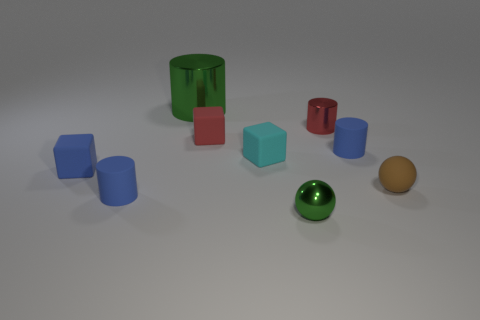Subtract all gray cylinders. Subtract all red blocks. How many cylinders are left? 4 Add 1 yellow shiny things. How many objects exist? 10 Subtract all balls. How many objects are left? 7 Subtract all small things. Subtract all small cyan blocks. How many objects are left? 0 Add 5 small shiny things. How many small shiny things are left? 7 Add 3 small balls. How many small balls exist? 5 Subtract 1 green cylinders. How many objects are left? 8 